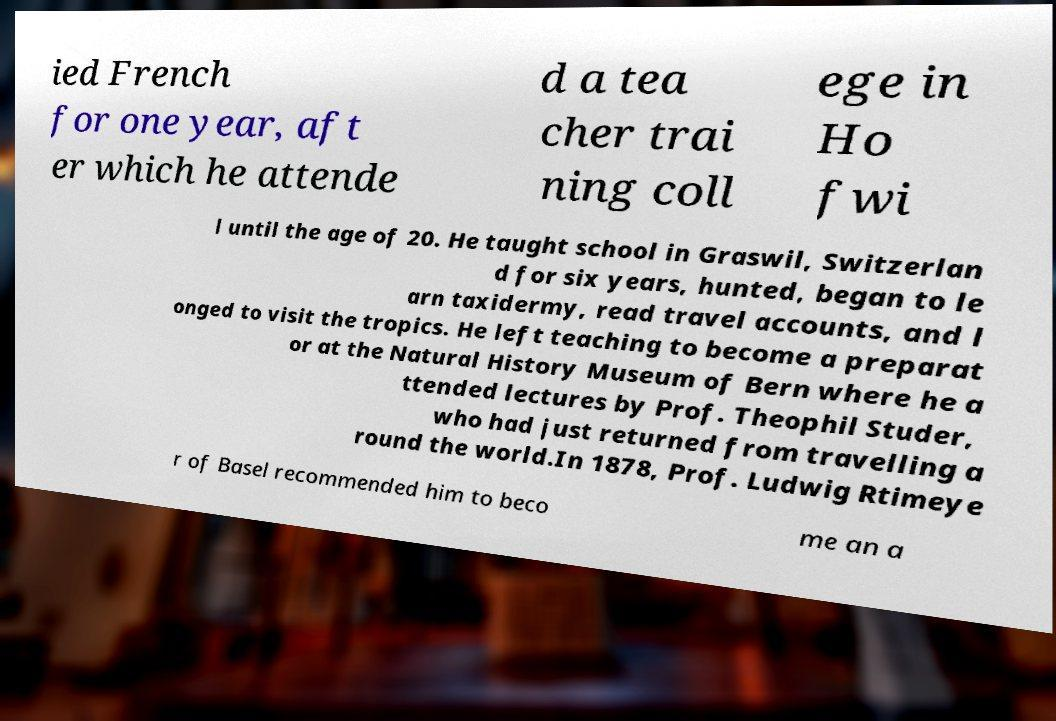Please identify and transcribe the text found in this image. ied French for one year, aft er which he attende d a tea cher trai ning coll ege in Ho fwi l until the age of 20. He taught school in Graswil, Switzerlan d for six years, hunted, began to le arn taxidermy, read travel accounts, and l onged to visit the tropics. He left teaching to become a preparat or at the Natural History Museum of Bern where he a ttended lectures by Prof. Theophil Studer, who had just returned from travelling a round the world.In 1878, Prof. Ludwig Rtimeye r of Basel recommended him to beco me an a 